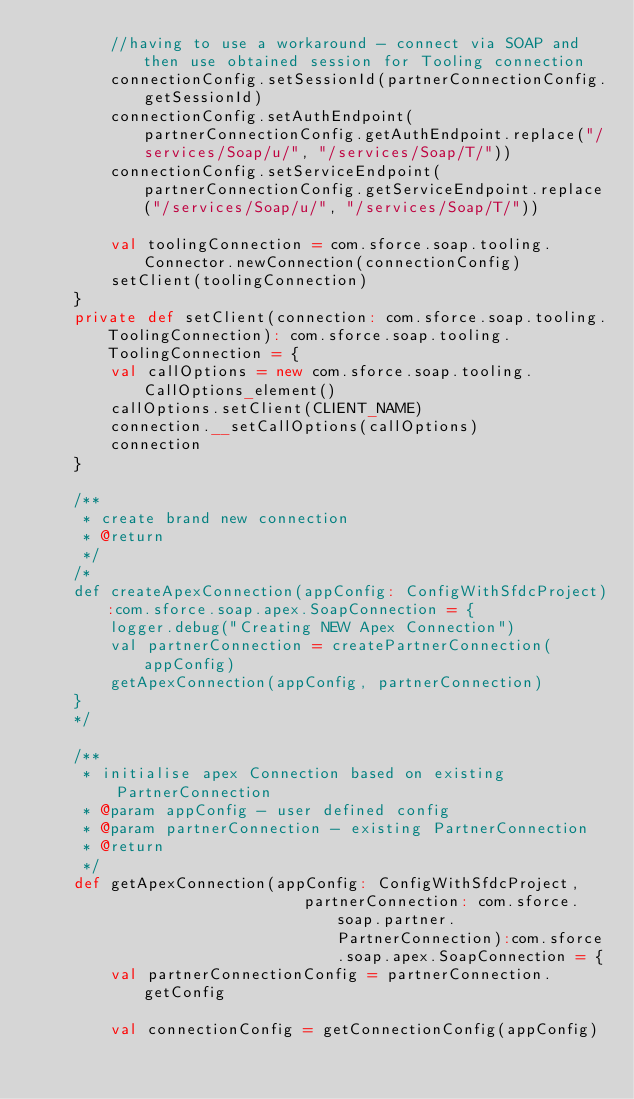<code> <loc_0><loc_0><loc_500><loc_500><_Scala_>        //having to use a workaround - connect via SOAP and then use obtained session for Tooling connection
        connectionConfig.setSessionId(partnerConnectionConfig.getSessionId)
        connectionConfig.setAuthEndpoint(partnerConnectionConfig.getAuthEndpoint.replace("/services/Soap/u/", "/services/Soap/T/"))
        connectionConfig.setServiceEndpoint(partnerConnectionConfig.getServiceEndpoint.replace("/services/Soap/u/", "/services/Soap/T/"))

        val toolingConnection = com.sforce.soap.tooling.Connector.newConnection(connectionConfig)
        setClient(toolingConnection)
    }
    private def setClient(connection: com.sforce.soap.tooling.ToolingConnection): com.sforce.soap.tooling.ToolingConnection = {
        val callOptions = new com.sforce.soap.tooling.CallOptions_element()
        callOptions.setClient(CLIENT_NAME)
        connection.__setCallOptions(callOptions)
        connection
    }

    /**
     * create brand new connection
     * @return
     */
    /*
    def createApexConnection(appConfig: ConfigWithSfdcProject):com.sforce.soap.apex.SoapConnection = {
        logger.debug("Creating NEW Apex Connection")
        val partnerConnection = createPartnerConnection(appConfig)
        getApexConnection(appConfig, partnerConnection)
    }
    */

    /**
     * initialise apex Connection based on existing PartnerConnection
     * @param appConfig - user defined config
     * @param partnerConnection - existing PartnerConnection
     * @return
     */
    def getApexConnection(appConfig: ConfigWithSfdcProject,
                             partnerConnection: com.sforce.soap.partner.PartnerConnection):com.sforce.soap.apex.SoapConnection = {
        val partnerConnectionConfig = partnerConnection.getConfig

        val connectionConfig = getConnectionConfig(appConfig)</code> 